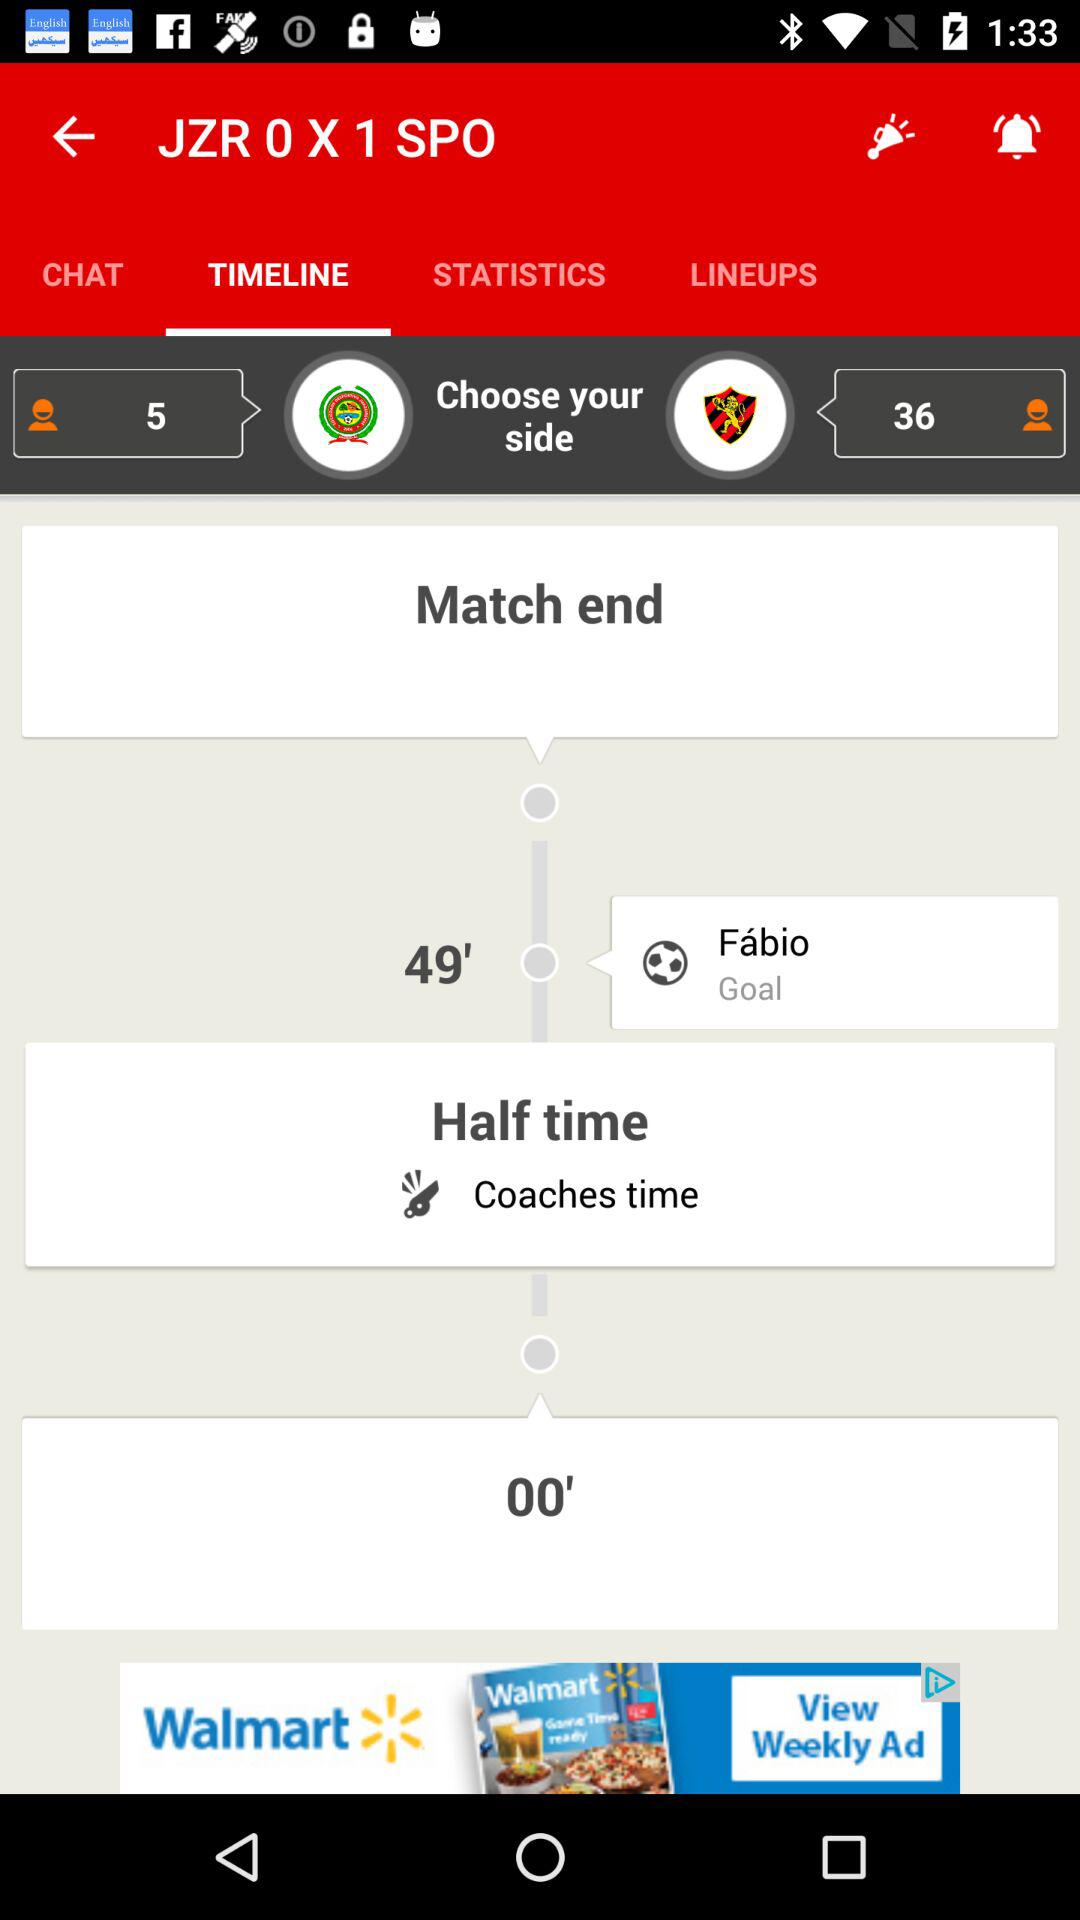How many goals have been scored in the game?
Answer the question using a single word or phrase. 1 